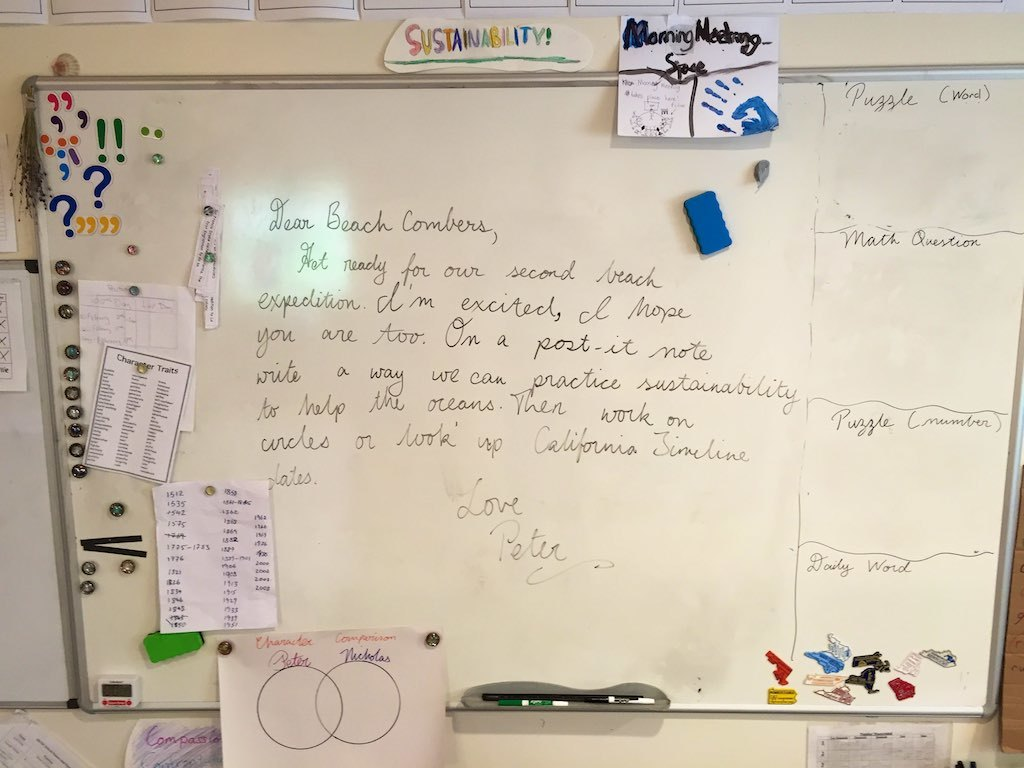What do you see happening in this image?
 The image captures a whiteboard that serves as a hub of communication and planning. Dominating the board is a note penned by someone named Petra, addressed to her "Long Beach Coworkers". She expresses her readiness and excitement for their second lunch expedition. Interestingly, she also brings up the topic of sustainability, suggesting the use of more sustainable circles or working up the California coastline. This note hints at a team that values not just camaraderie, but also environmental consciousness.

In addition to Petra's note, the board features a simple drawing of two circles. Various objects are attached to the board, including magnets and markers, indicating its use as a common space for sharing ideas and messages. A key hangs from the board as well, perhaps a symbol of trust within this group. Overall, the whiteboard presents a snapshot of a vibrant, collaborative, and eco-conscious team culture. 